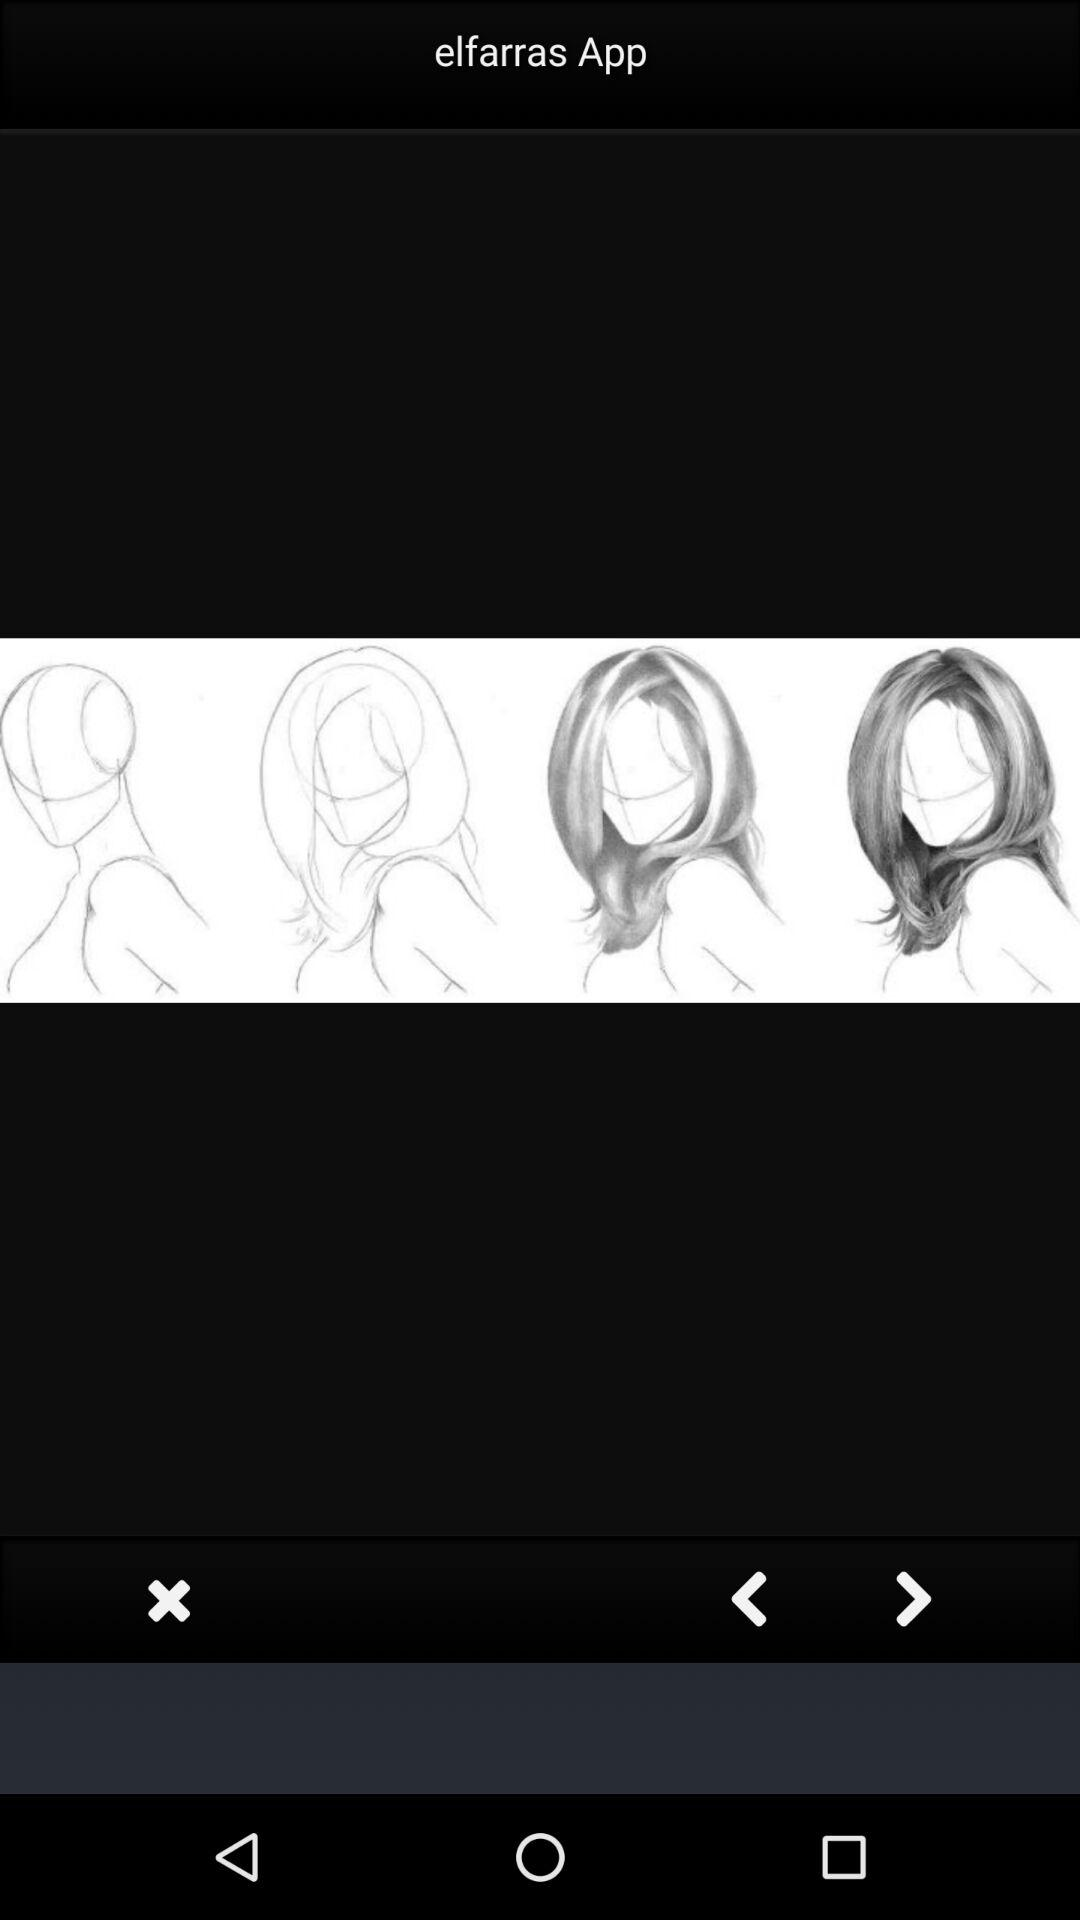When was "elfarras App" released?
When the provided information is insufficient, respond with <no answer>. <no answer> 